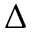Convert formula to latex. <formula><loc_0><loc_0><loc_500><loc_500>\Delta</formula> 